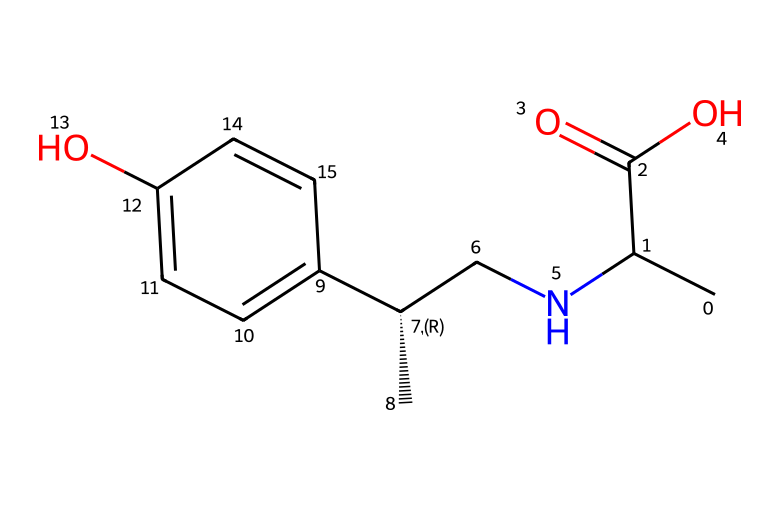What is the primary functional group present in p-synephrine? The structure features a hydroxyl group (-OH) attached to a carbon atom within a benzene ring, which characterizes it as a phenol.
Answer: hydroxyl group How many carbon atoms are in p-synephrine? By analyzing the chemical structure, we count a total of 12 carbon atoms present in the backbone, including those in the phenolic ring and aliphatic chain.
Answer: 12 What type of nitrogen is present in p-synephrine? The nitrogen atom is part of an amine group (-NH) bonded to a carbon chain, indicating it is a primary amine due to the presence of two hydrogen atoms attached to nitrogen.
Answer: primary amine What is the total number of hydrogen atoms in p-synephrine? In total, p-synephrine has 17 hydrogen atoms, which can be calculated by counting the hydrogens connected to each carbon and nitrogen atom based on typical valency.
Answer: 17 Which part of p-synephrine contributes to its potential stimulant properties? The presence of the amine group (-NH) contributes to its stimulant effects, as nitrogen-containing compounds often have physiological activity, including stimulation of the nervous system.
Answer: amine group What is the relationship between p-synephrine and energy drinks? p-synephrine is a common ingredient in energy drinks due to its role as a stimulant, helping to enhance performance and alertness during athletic activities.
Answer: stimulant 